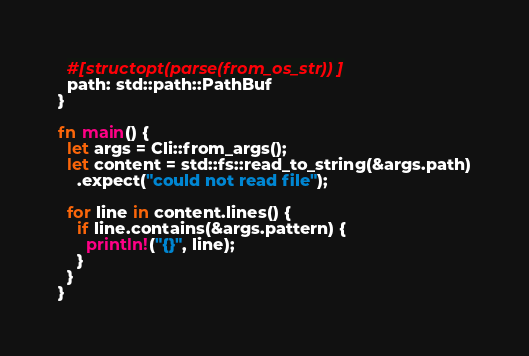<code> <loc_0><loc_0><loc_500><loc_500><_Rust_>  #[structopt(parse(from_os_str))]
  path: std::path::PathBuf
}

fn main() {
  let args = Cli::from_args();
  let content = std::fs::read_to_string(&args.path)
    .expect("could not read file");
  
  for line in content.lines() {
    if line.contains(&args.pattern) {
      println!("{}", line);
    }
  }
}
</code> 